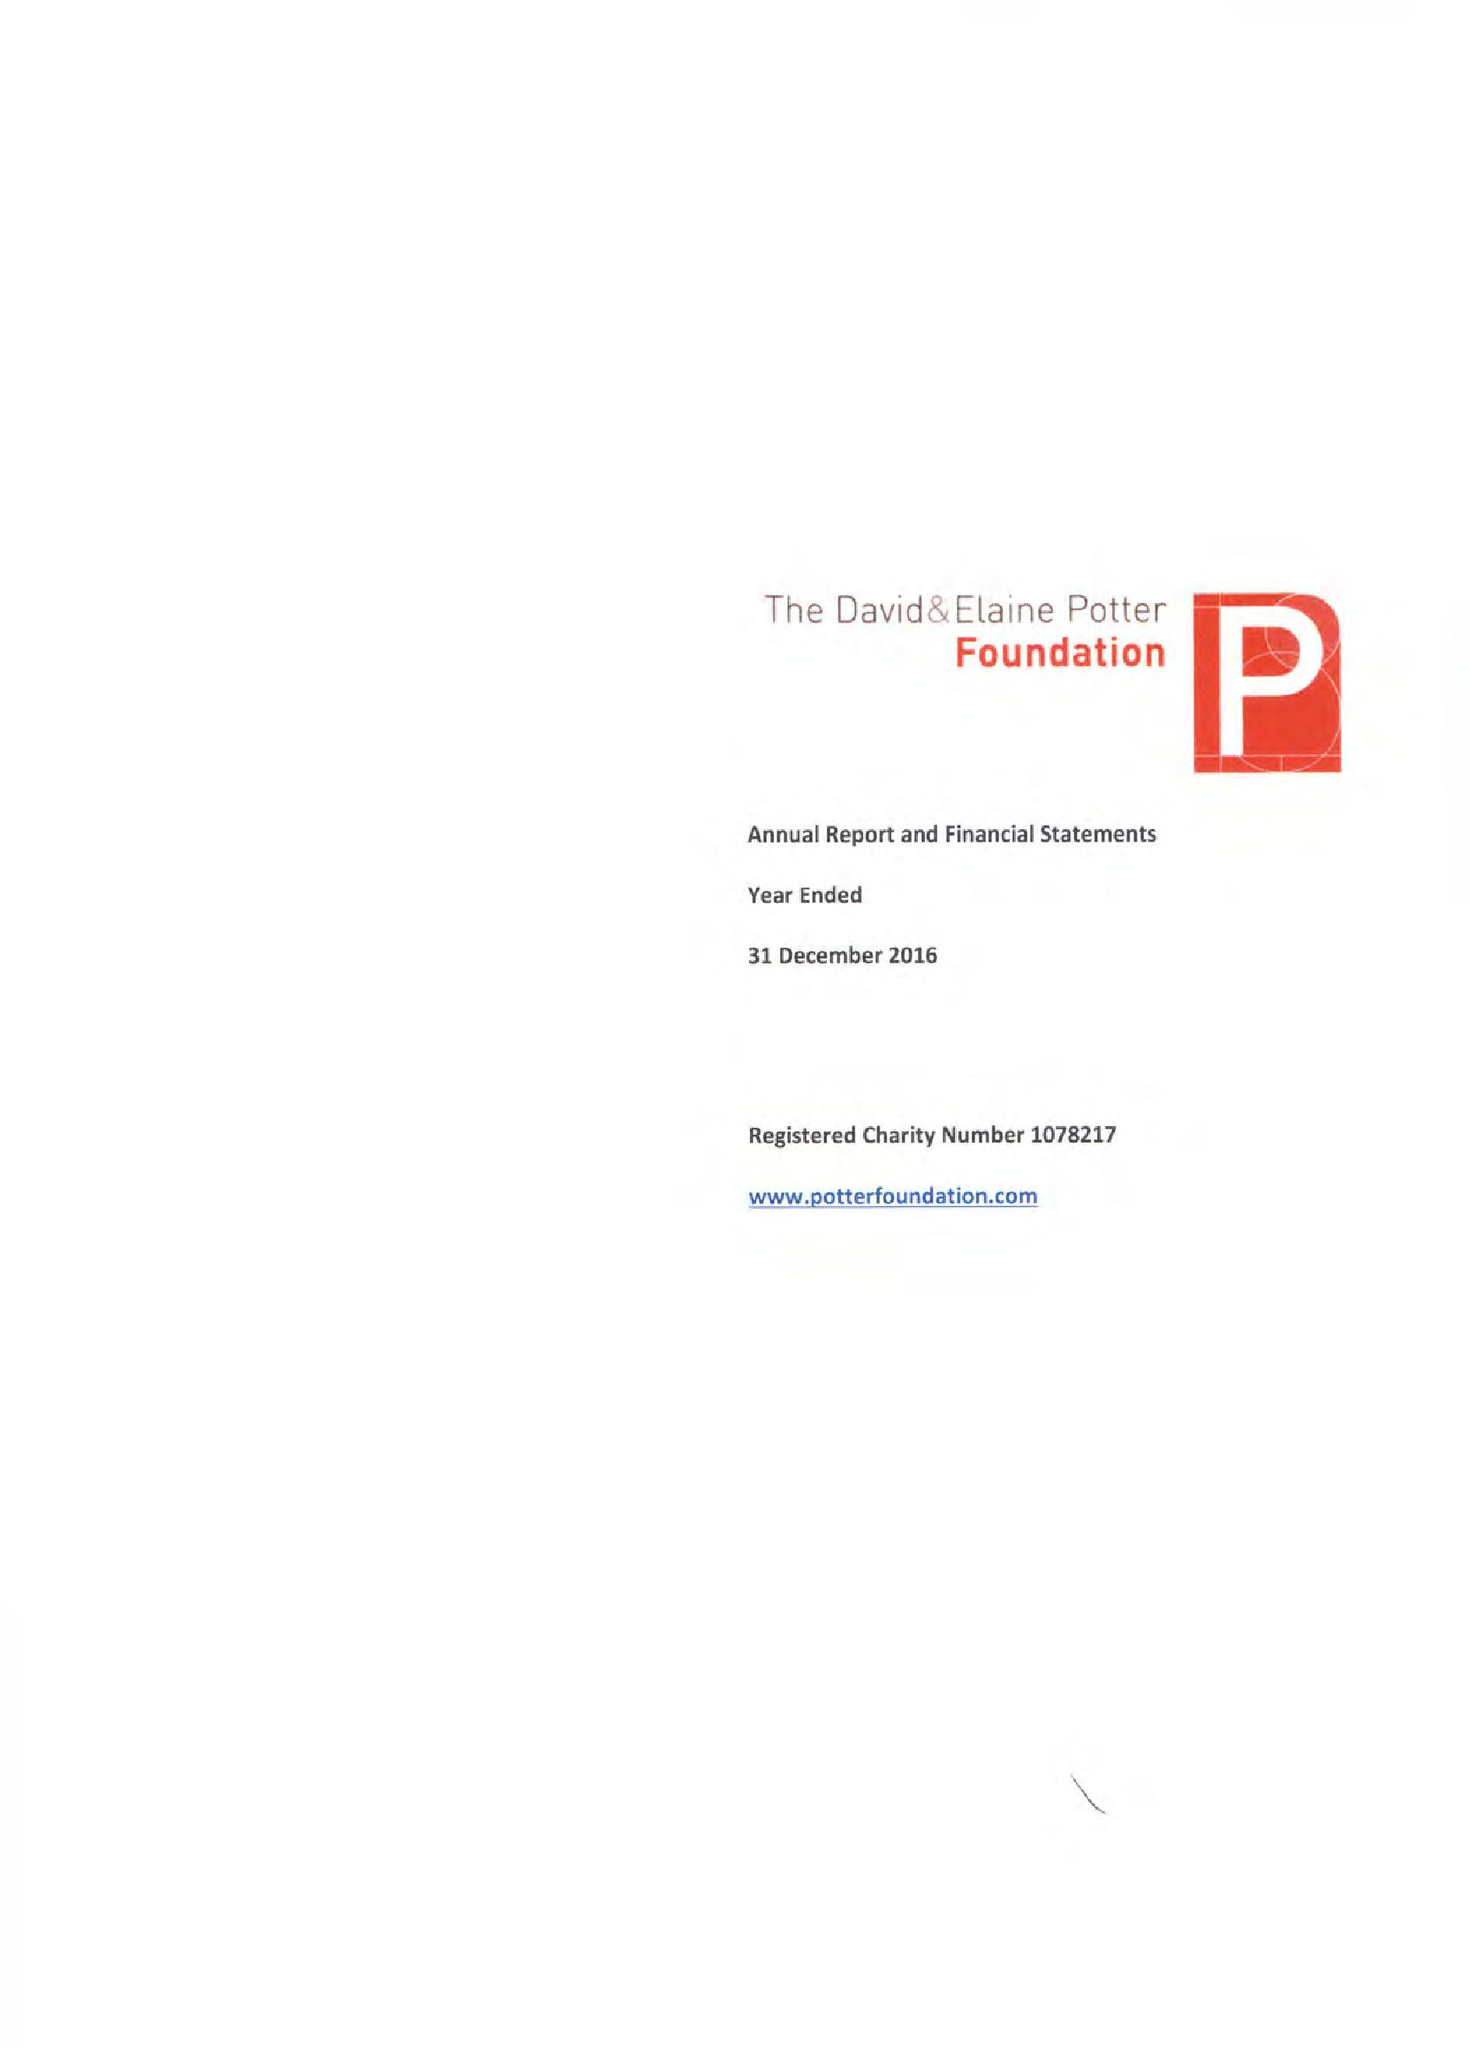What is the value for the charity_name?
Answer the question using a single word or phrase. David and Elaine Potter Foundation 